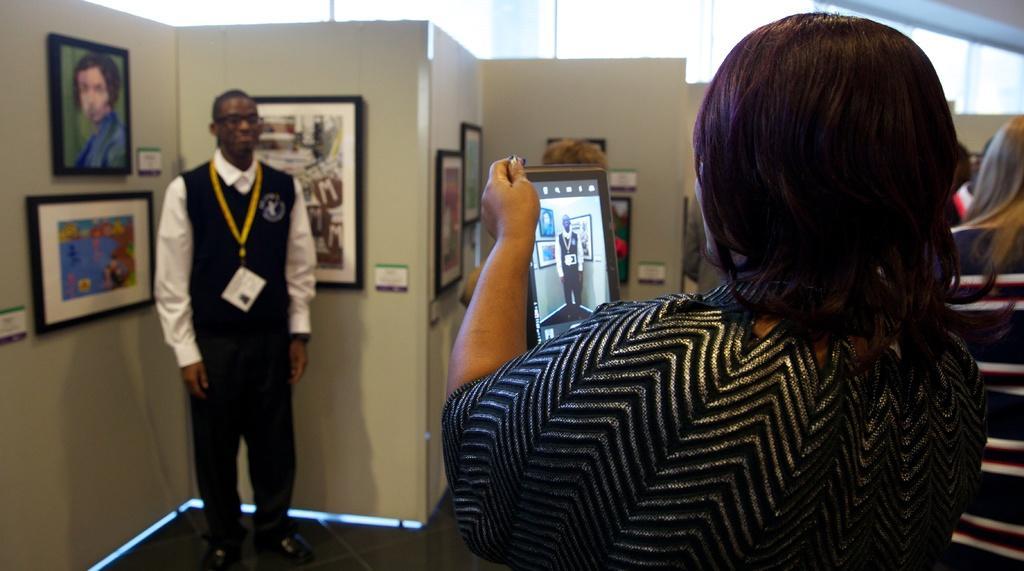Describe this image in one or two sentences. In this image we can see few persons. In the foreground we can see a person taking a photo. Behind the persons we can see a wall. On the wall we can see the photo frames. At the top we can see the glass. 